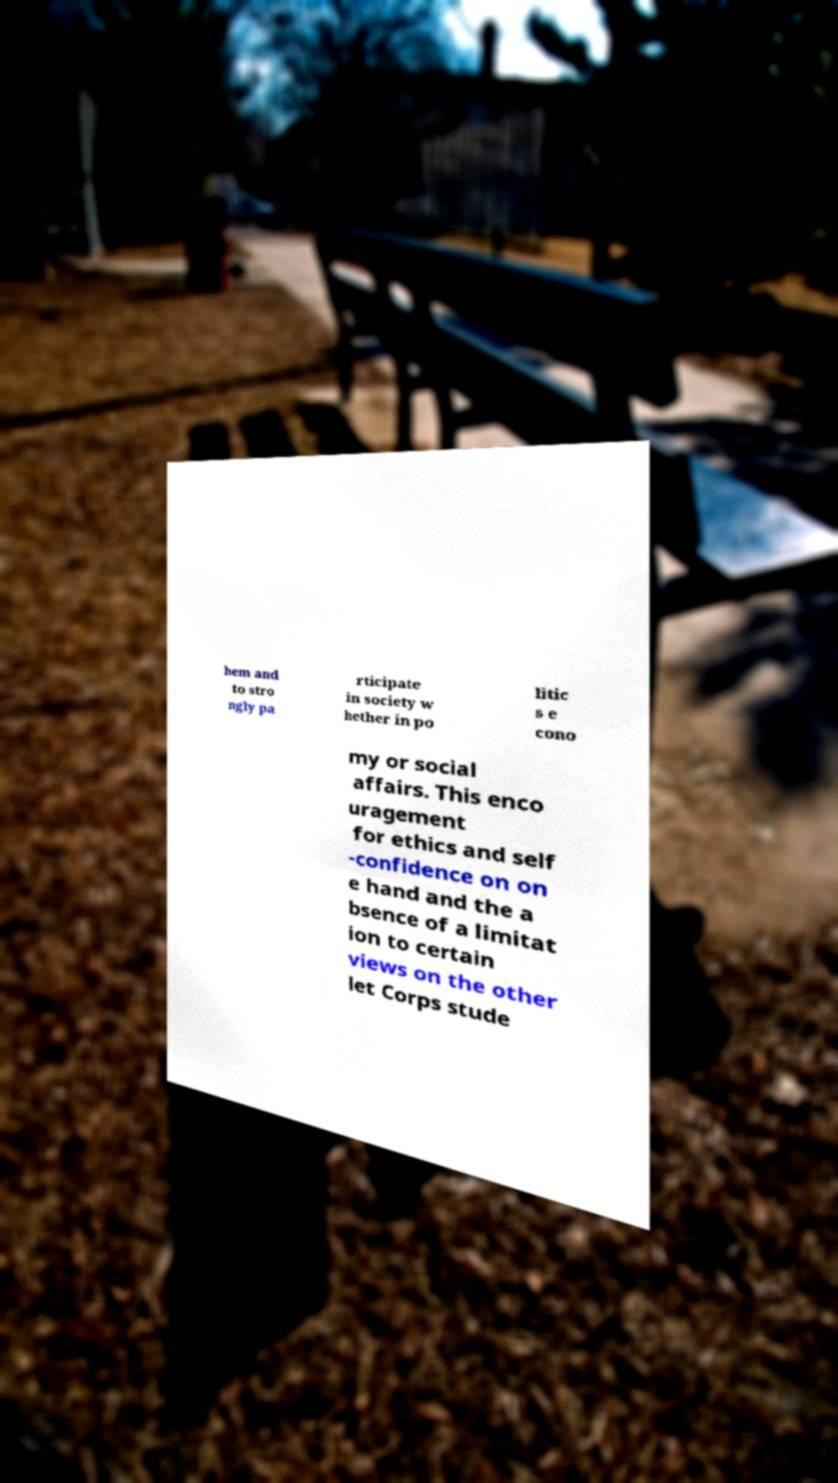Please identify and transcribe the text found in this image. hem and to stro ngly pa rticipate in society w hether in po litic s e cono my or social affairs. This enco uragement for ethics and self -confidence on on e hand and the a bsence of a limitat ion to certain views on the other let Corps stude 